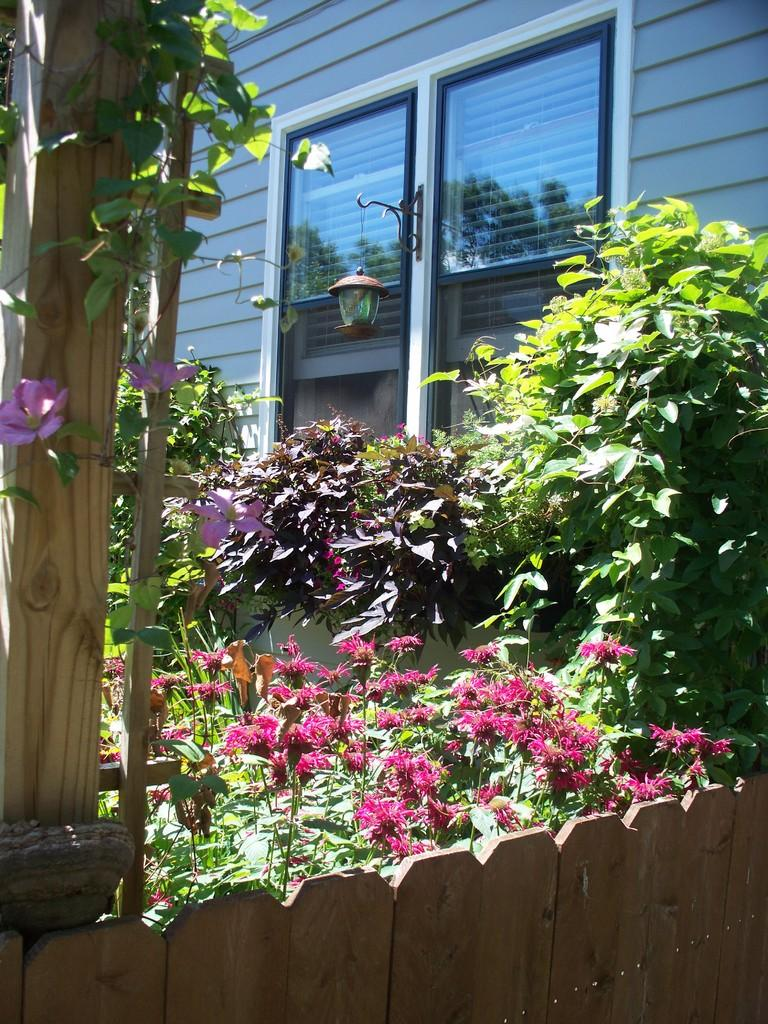What type of structure is visible in the image? There is a building in the image. What can be seen in the foreground of the image? There is a window in the foreground of the image. Can you describe any lighting features in the image? There is a light on the wall in the image. What type of vegetation is present in the image? There are plants and flowers in the image. What material is used for the railing in the image? There is a wooden railing in the image. Can you see any kites flying near the seashore in the image? There is no seashore or kites present in the image. What type of crack is visible on the wooden railing in the image? There is no crack visible on the wooden railing in the image. 